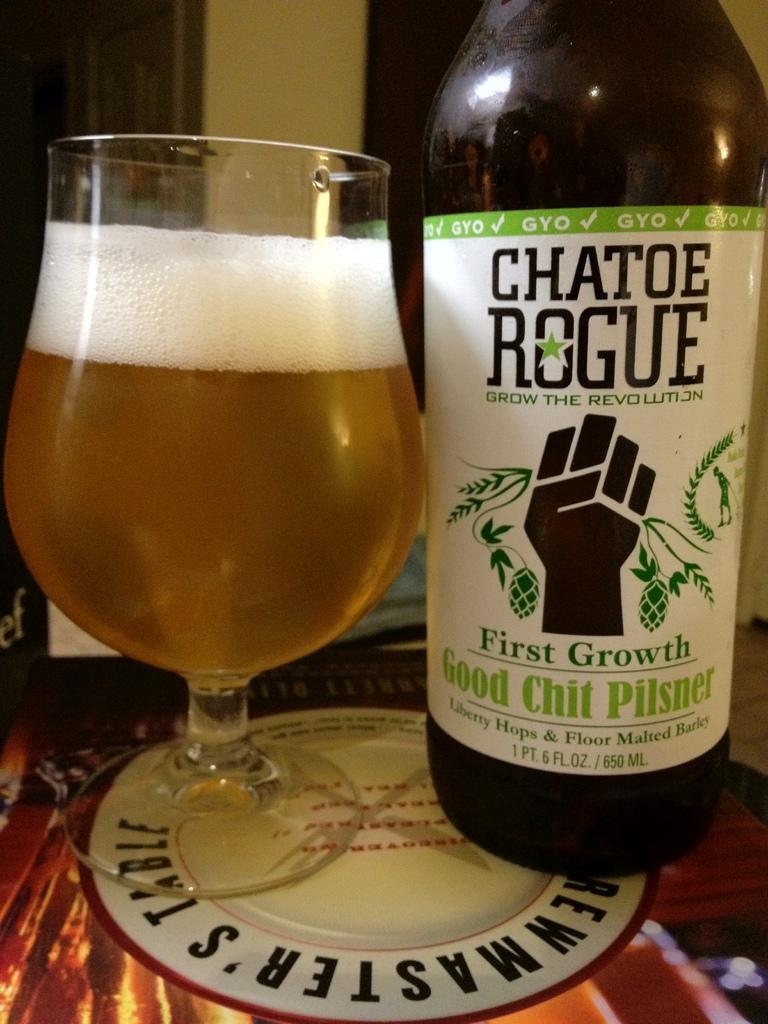<image>
Give a short and clear explanation of the subsequent image. A bottle of Chatoe Rogue sits next to a glass. 